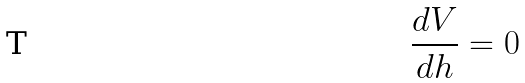<formula> <loc_0><loc_0><loc_500><loc_500>\frac { d V } { d h } = 0</formula> 